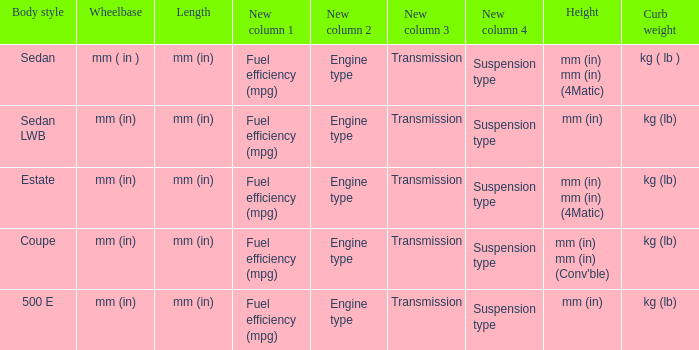What are the lengths of the models that are mm (in) tall? Mm (in), mm (in). 